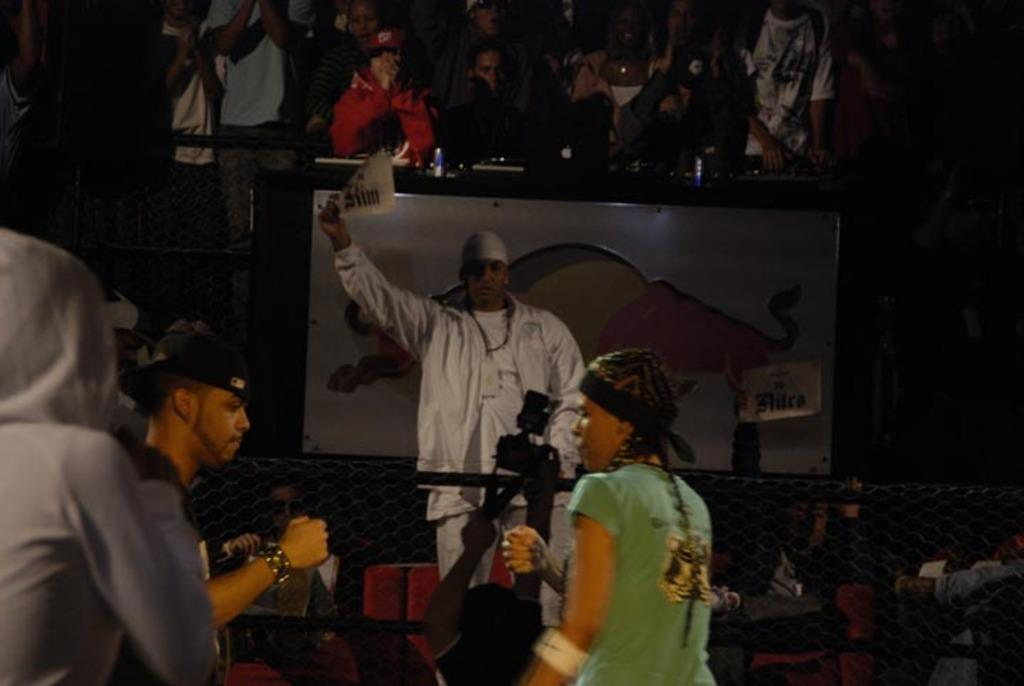How many people are in the image? There is a group of people in the image, but the exact number cannot be determined from the provided facts. What is the purpose of the screen in the image? The purpose of the screen in the image cannot be determined from the provided facts. What is the fence used for in the image? The purpose of the fence in the image cannot be determined from the provided facts. What type of objects can be seen in the image? There are objects in the image, but their specific types cannot be determined from the provided facts. What is the board used for in the image? The purpose of the board in the image cannot be determined from the provided facts. Can you tell if the image was taken during the day or night? The image may have been taken during the night, but this cannot be confirmed with certainty based on the provided facts. Where is the straw basket located in the image? There is no straw basket present in the image. Can you describe the snake that is slithering across the board in the image? There is no snake present in the image. 